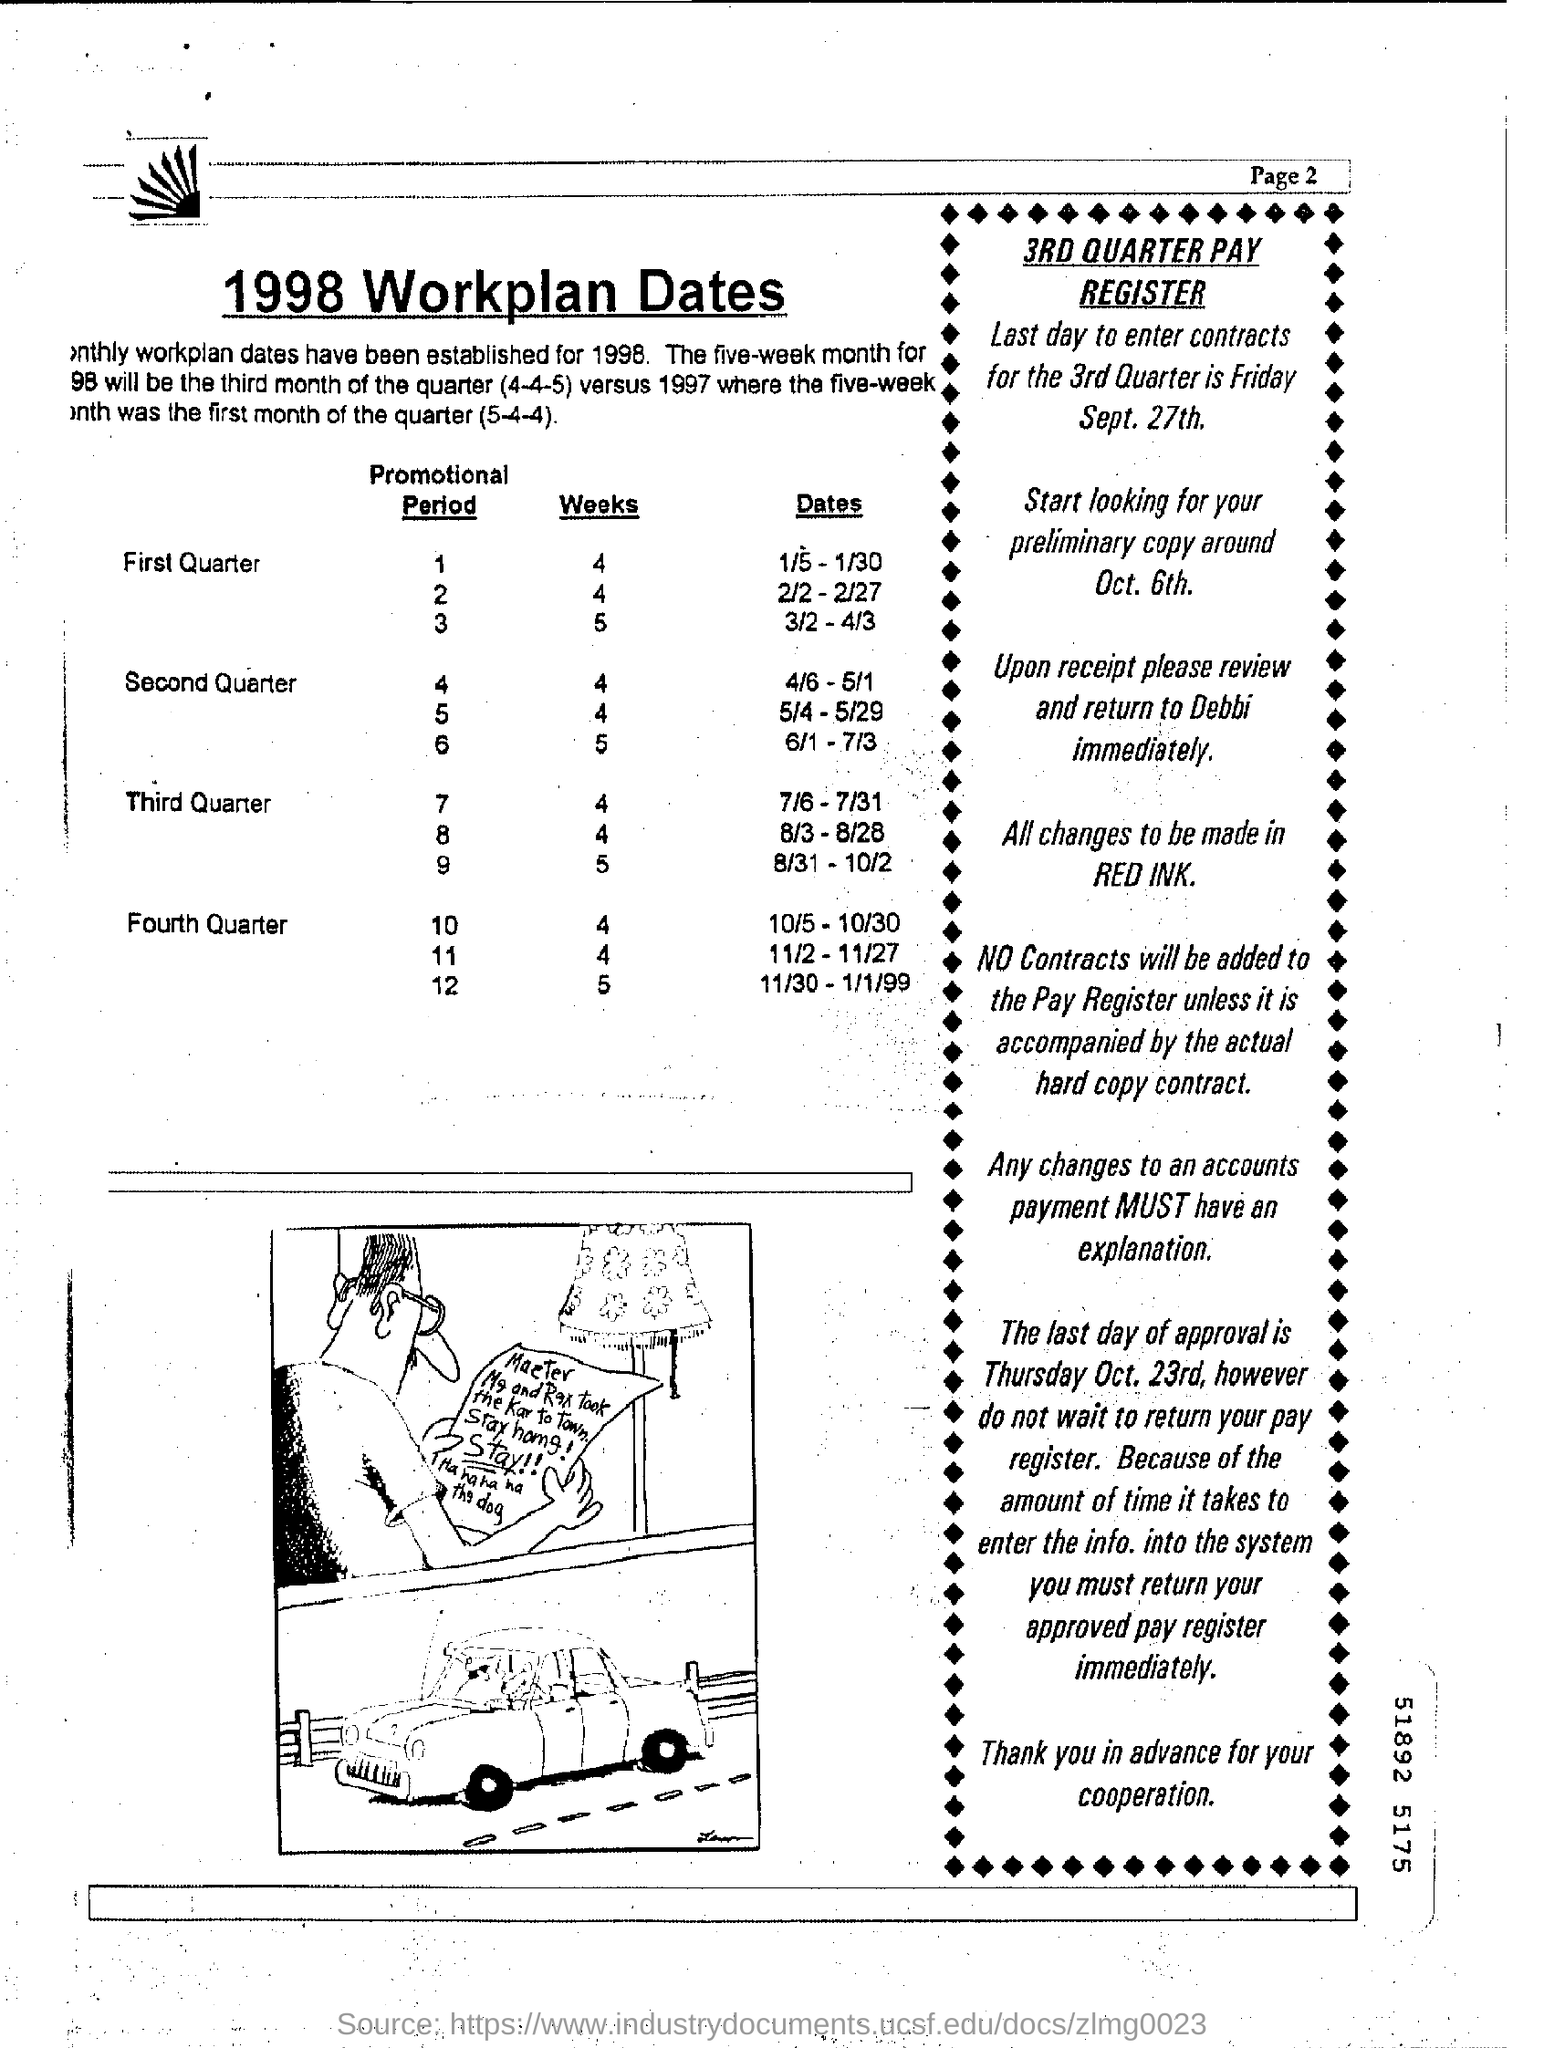Point out several critical features in this image. The last day to enter contracts for the third quarter is Friday, September 27th. The last day of approval is Thursday, October 23rd. 